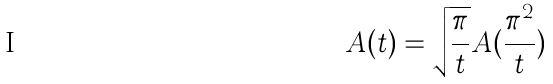<formula> <loc_0><loc_0><loc_500><loc_500>A ( t ) = \sqrt { \frac { \pi } { t } } A ( \frac { \pi ^ { 2 } } { t } )</formula> 